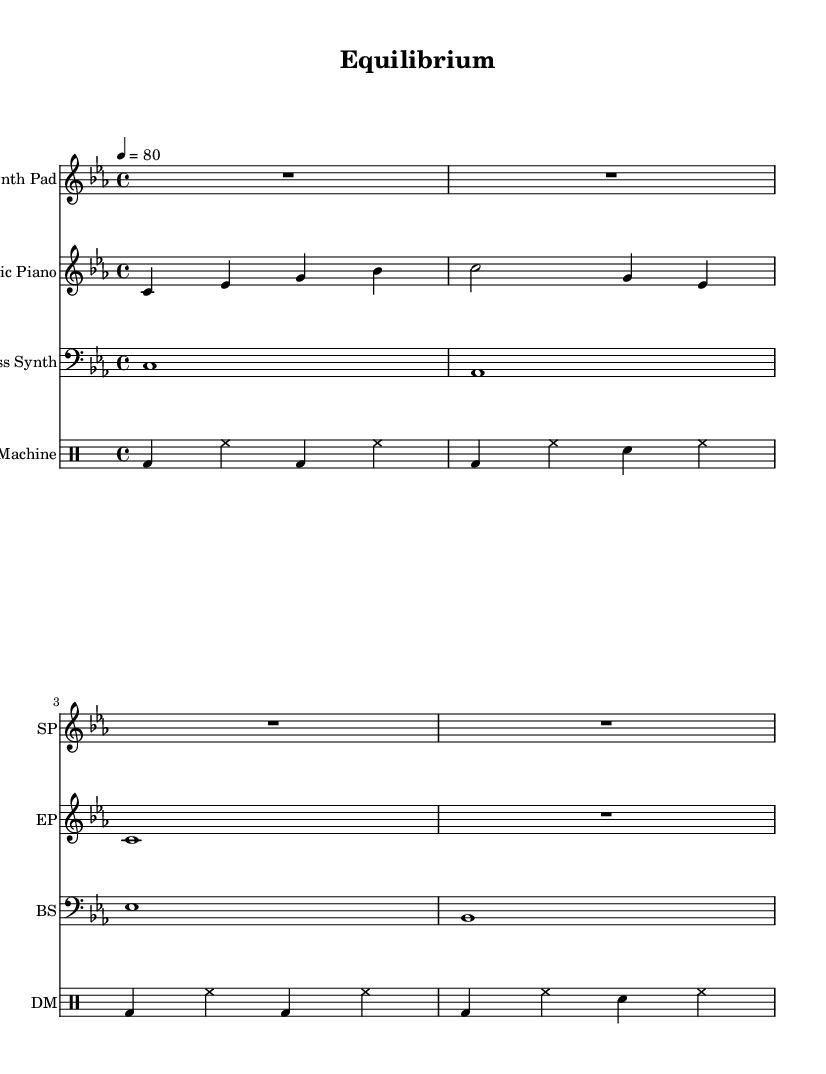what is the key signature of this music? The key signature is C minor, which has three flats: B flat, E flat, and A flat. This is confirmed by examining the key signature indicated at the beginning of the staff.
Answer: C minor what is the time signature of this music? The time signature is 4/4, which means there are four beats in each measure and the quarter note receives one beat. This information is indicated at the beginning of the score, just after the key signature.
Answer: 4/4 what is the tempo marking for this piece? The tempo marking is 80 beats per minute, as specified in the score. It is written using the term "tempo" followed by the number of beats per minute.
Answer: 80 how many measures are there in the Electric Piano part? The Electric Piano part has a total of four measures, which can be counted by examining the vertical bar lines that separate each measure in the staff.
Answer: 4 which instruments are included in this music? The instruments included in this music are Synth Pad, Electric Piano, Bass Synth, and Drum Machine. Each instrument has a dedicated staff at the beginning of the score, with specific names indicating their type.
Answer: Synth Pad, Electric Piano, Bass Synth, Drum Machine what type of electronic music is represented in this score? The type of electronic music represented is ambient music, as reflected by the soft chords and textural layers that create an atmospheric sound, typical for the genre. The overall composition mimics an interplay between human elements and natural resources.
Answer: Ambient music 